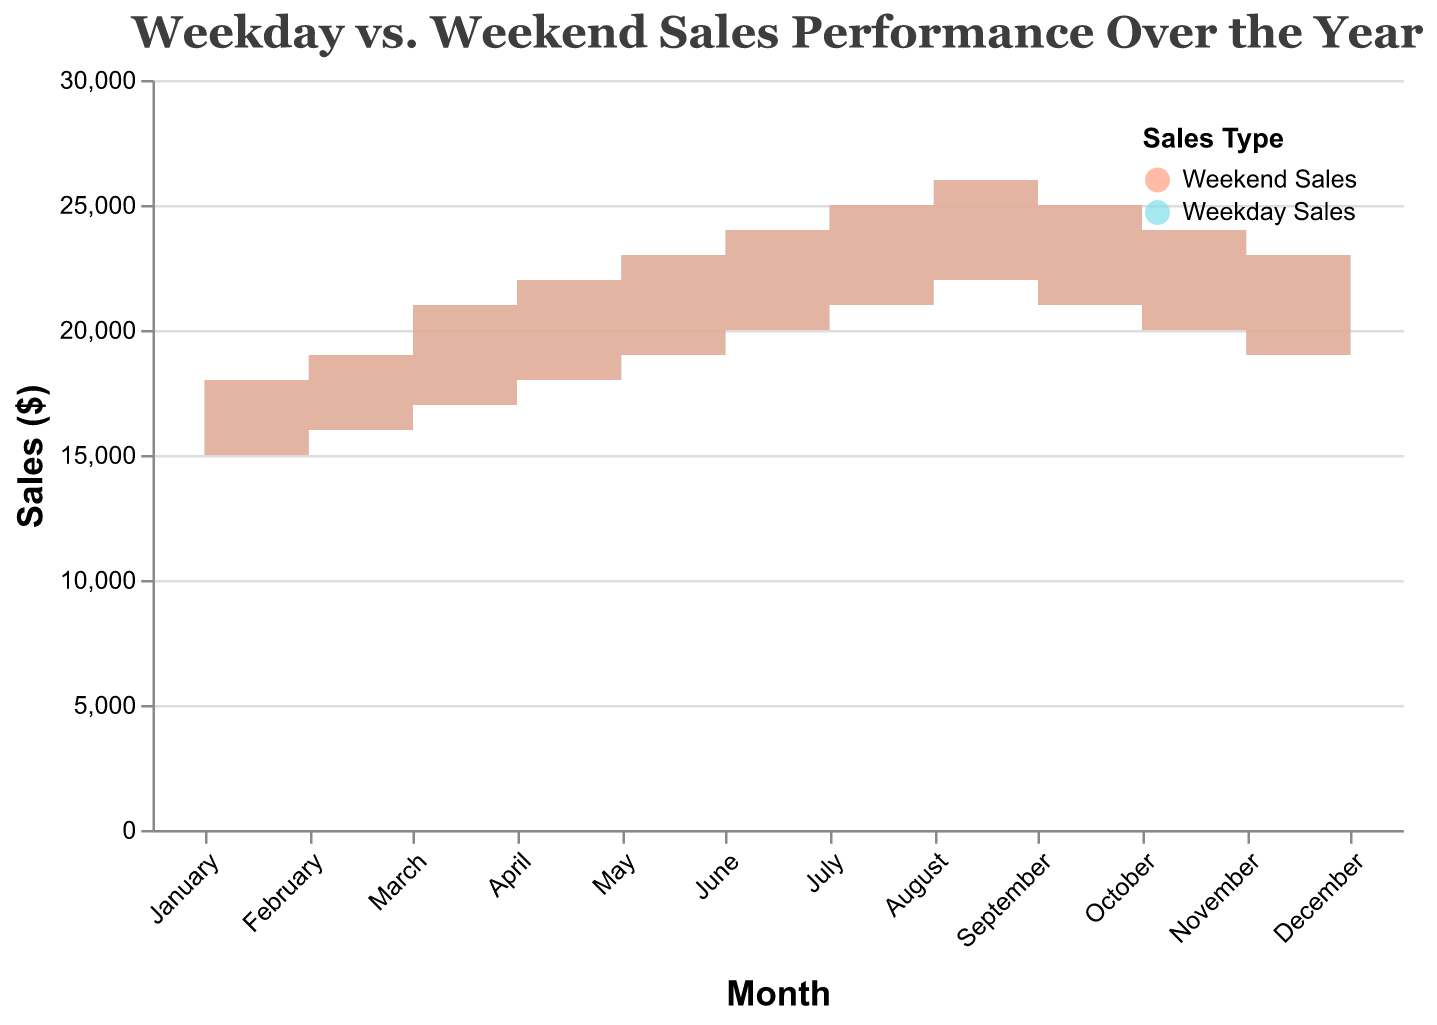What is the title of the chart? The title of the chart is located at the top center and provides a summary of what the chart represents.
Answer: Weekday vs. Weekend Sales Performance Over the Year Which month has the highest weekend sales? By observing the highest peak on the "Weekend Sales" area of the chart, we can determine which month it corresponds to.
Answer: December How much more were the weekend sales compared to weekday sales in July? Look at the values for July and calculate the difference between Weekend Sales and Weekday Sales: 25000 - 21000 = 4000
Answer: 4000 In which month do the weekday and weekend sales have the smallest difference? Visually compare the difference between the weekday and weekend areas for each month and see which has the smallest gap.
Answer: January Which months have higher weekday sales compared to October's weekday sales? Identify the months where the area for weekday sales is above the level for October's weekday sales (20000).
Answer: August, December What is the total weekday sales for the first quarter of the year? Sum the weekday sales values for January, February, and March: 15000 + 16000 + 17000 = 48000
Answer: 48000 Compare the sales trends between weekdays and weekends. Which period shows a more steady increase? By analyzing the trends represented by the area changes, note which period shows consistent month-over-month increases.
Answer: Weekday sales What is the sales gap between weekends and weekdays in November? Subtract weekday sales from weekend sales in November: 23000 - 19000 = 4000
Answer: 4000 During which month do we observe the steepest increase in weekend sales? Identify the month with the steepest slope in the "Weekend Sales" area, which signifies the most significant increase.
Answer: March What is the average sales value for weekends in the second half of the year? Add the weekend sales for July to December and divide by 6: (25000 + 26000 + 25000 + 24000 + 23000 + 27000) / 6 = 25000
Answer: 25000 